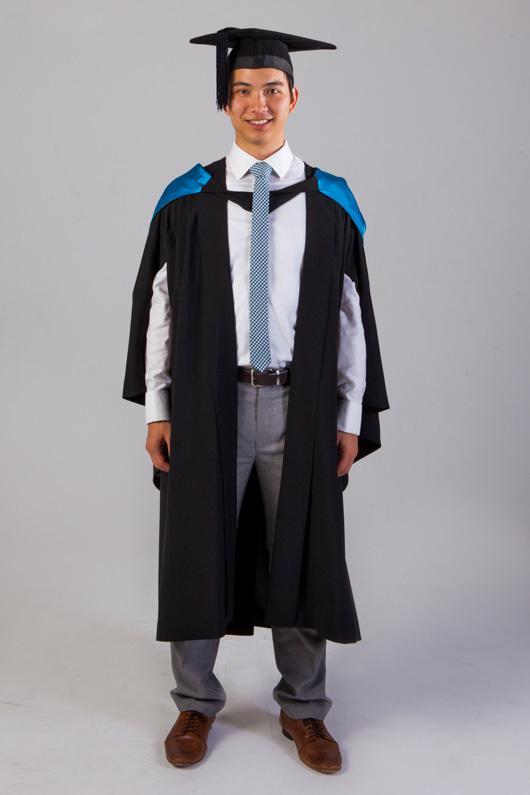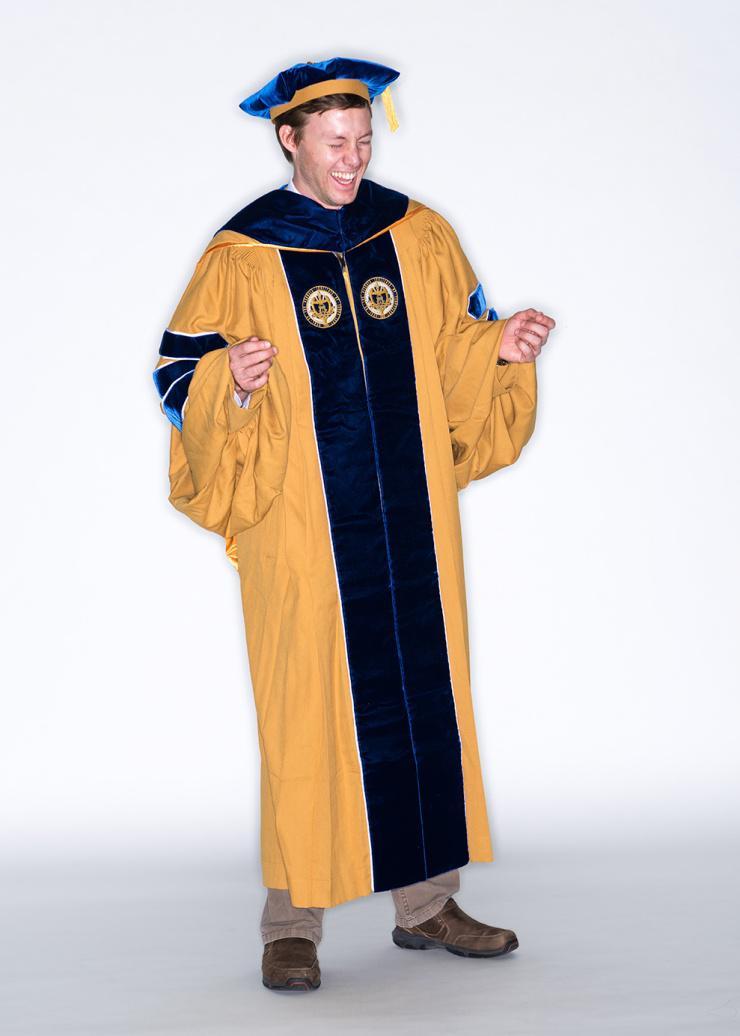The first image is the image on the left, the second image is the image on the right. For the images shown, is this caption "The man on the left has a yellow tassel." true? Answer yes or no. No. 